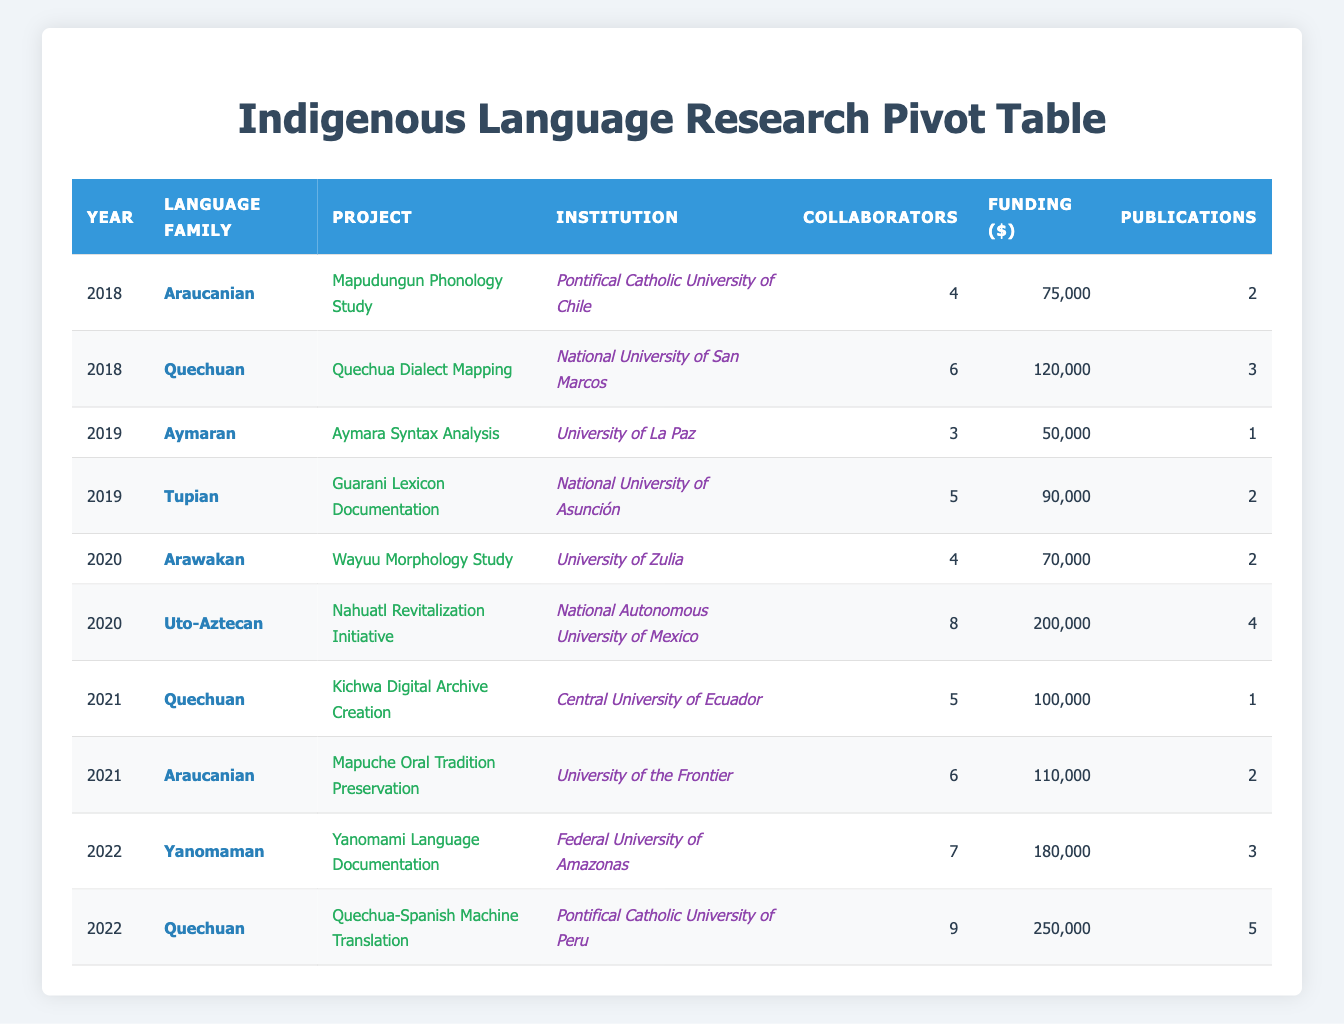What is the total funding for all projects in 2020? To find the total funding for all projects in 2020, we identify the two projects listed for that year: "Wayuu Morphology Study" with funding of 70,000 and "Nahuatl Revitalization Initiative" with funding of 200,000. Adding these amounts together (70,000 + 200,000) results in a total funding of 270,000.
Answer: 270,000 Which project had the most collaborators in 2022? In 2022, there are two projects: "Yanomami Language Documentation" with 7 collaborators and "Quechua-Spanish Machine Translation" with 9 collaborators. Between these, "Quechua-Spanish Machine Translation" has the highest number of collaborators at 9.
Answer: 9 How many publications were produced across all projects in 2019? We look at the two projects from 2019: "Aymara Syntax Analysis" producing 1 publication and "Guarani Lexicon Documentation" producing 2 publications. Adding these together (1 + 2) gives a total of 3 publications produced in 2019.
Answer: 3 Is the funding for the "Quechua-Spanish Machine Translation" project greater than the funding for the "Mapuche Oral Tradition Preservation" project? The "Quechua-Spanish Machine Translation" project received 250,000 in funding, while the "Mapuche Oral Tradition Preservation" project received 110,000. Since 250,000 is greater than 110,000, the answer is yes.
Answer: Yes What is the average number of collaborators for projects in the Araucanian language family? There are two projects in the Araucanian language family: "Mapudungun Phonology Study" with 4 collaborators and "Mapuche Oral Tradition Preservation" with 6 collaborators. To find the average, we sum the collaborators (4 + 6 = 10) and divide by the number of projects (2); thus, the average number of collaborators is 10/2 = 5.
Answer: 5 How many institutions collaborated on projects in 2021? In 2021, there are two projects: "Kichwa Digital Archive Creation" from the Central University of Ecuador and "Mapuche Oral Tradition Preservation" from the University of the Frontier. Since both come from different institutions, the number of institutions involved is 2.
Answer: 2 Which language family had the highest total funding across all projects? To find out which language family received the highest total funding, we must sum the funding for each project grouped by language family. Araucanian has projects totaling 75,000 + 110,000 = 185,000; Quechuan has 120,000 + 100,000 + 250,000 = 470,000; Aymaran has 50,000; Tupian has 90,000; Arawakan has 70,000; Uto-Aztecan has 200,000; Yanomaman has 180,000. The highest funding total is from the Quechuan family with 470,000.
Answer: Quechuan How many publications were produced by all projects in 2018? In 2018, the two projects were "Mapudungun Phonology Study" producing 2 publications and "Quechua Dialect Mapping" producing 3 publications. We can add these two values to find the total publications for 2018, which is 2 + 3 = 5.
Answer: 5 